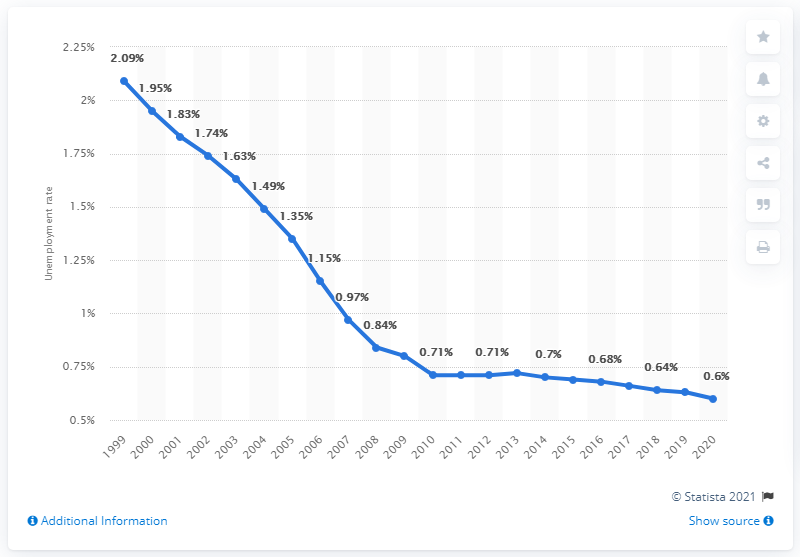Point out several critical features in this image. In 2020, the unemployment rate in Laos was 0.6%. 